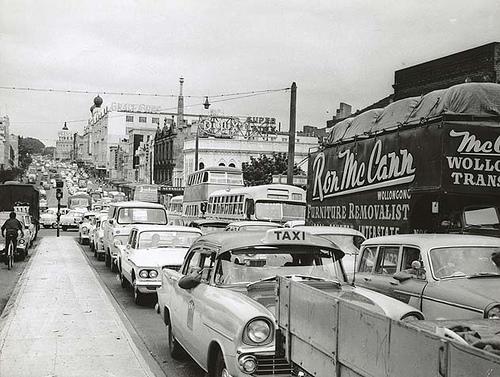What is the man on the left side of the picture riding?
Quick response, please. Bicycle. What is the passenger of the car behind the taxi doing?
Give a very brief answer. Talking. Are the cars on a bridge?
Quick response, please. No. 